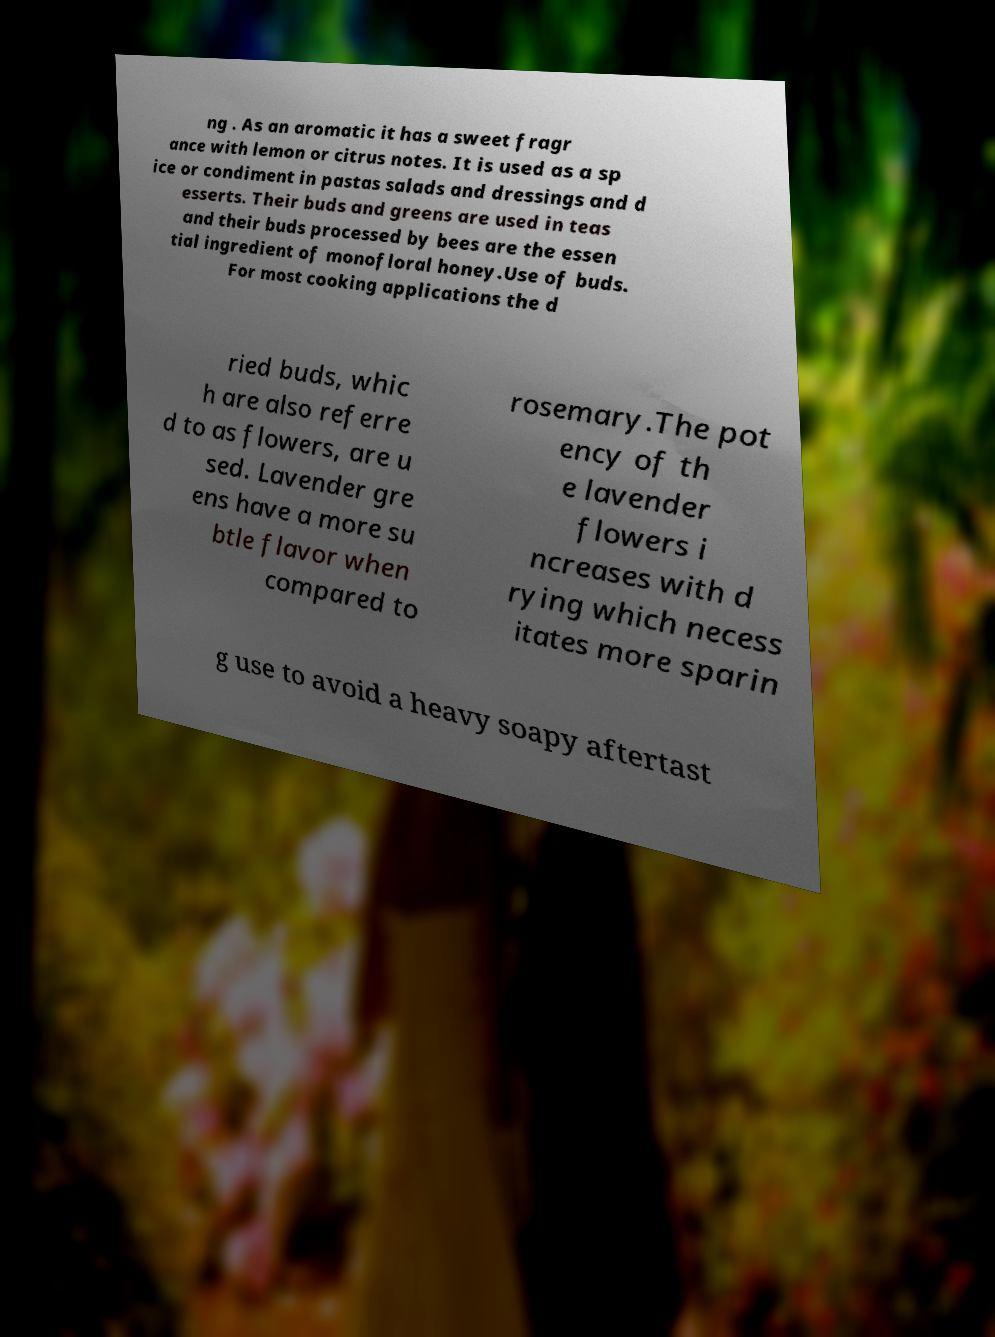What messages or text are displayed in this image? I need them in a readable, typed format. ng . As an aromatic it has a sweet fragr ance with lemon or citrus notes. It is used as a sp ice or condiment in pastas salads and dressings and d esserts. Their buds and greens are used in teas and their buds processed by bees are the essen tial ingredient of monofloral honey.Use of buds. For most cooking applications the d ried buds, whic h are also referre d to as flowers, are u sed. Lavender gre ens have a more su btle flavor when compared to rosemary.The pot ency of th e lavender flowers i ncreases with d rying which necess itates more sparin g use to avoid a heavy soapy aftertast 